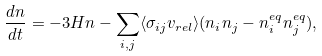<formula> <loc_0><loc_0><loc_500><loc_500>\frac { d n } { d t } = - 3 H n - \sum _ { i , j } \langle \sigma _ { i j } v _ { r e l } \rangle ( n _ { i } n _ { j } - n ^ { e q } _ { i } n ^ { e q } _ { j } ) ,</formula> 